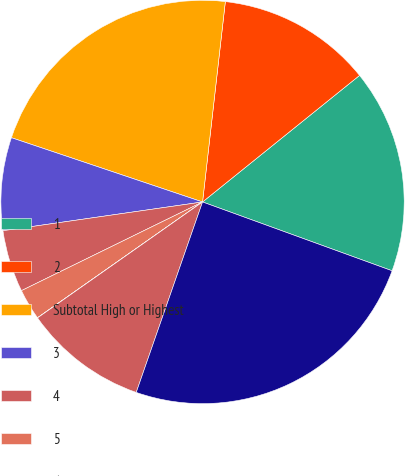Convert chart. <chart><loc_0><loc_0><loc_500><loc_500><pie_chart><fcel>1<fcel>2<fcel>Subtotal High or Highest<fcel>3<fcel>4<fcel>5<fcel>6<fcel>Subtotal Other Securities(2)<fcel>Total Public Fixed Maturities<nl><fcel>16.34%<fcel>12.4%<fcel>21.64%<fcel>7.44%<fcel>4.97%<fcel>2.49%<fcel>0.01%<fcel>9.92%<fcel>24.79%<nl></chart> 